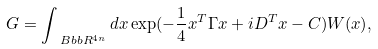Convert formula to latex. <formula><loc_0><loc_0><loc_500><loc_500>G = \int _ { \ B b b { R } ^ { 4 n } } d x \exp ( - \frac { 1 } { 4 } x ^ { T } \Gamma x + i D ^ { T } x - C ) W ( x ) ,</formula> 